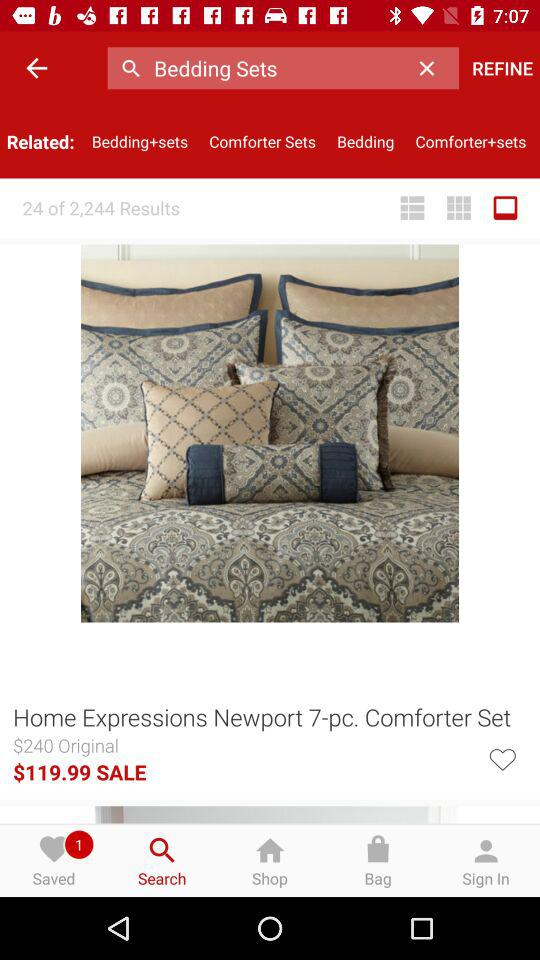How many results in total are shown? The total number of shown results is 24. 